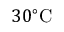Convert formula to latex. <formula><loc_0><loc_0><loc_500><loc_500>3 0 ^ { \circ } C</formula> 